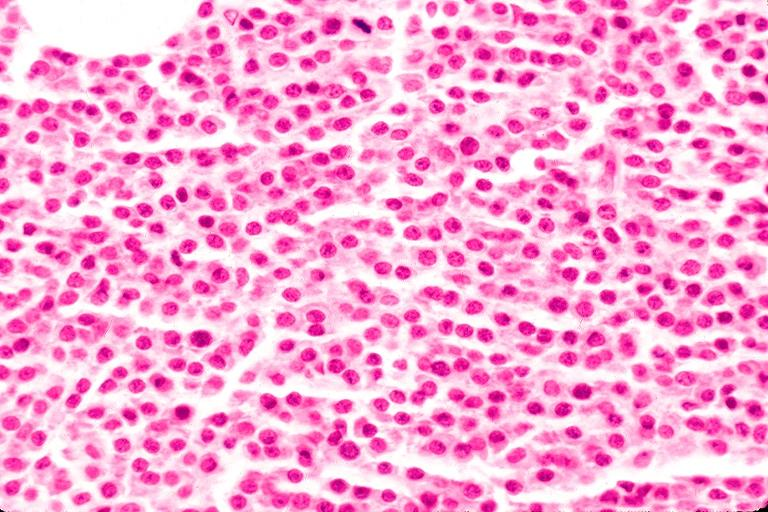does this good yellow color slide show multiple myeloma?
Answer the question using a single word or phrase. No 